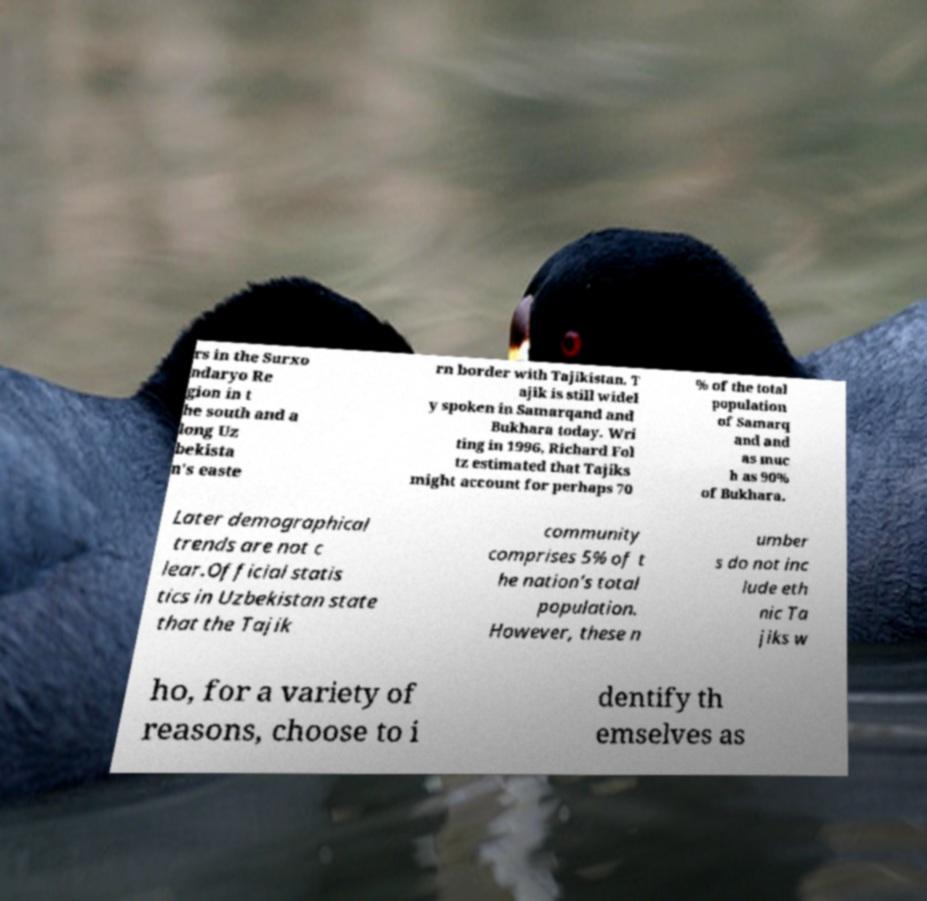There's text embedded in this image that I need extracted. Can you transcribe it verbatim? rs in the Surxo ndaryo Re gion in t he south and a long Uz bekista n's easte rn border with Tajikistan. T ajik is still widel y spoken in Samarqand and Bukhara today. Wri ting in 1996, Richard Fol tz estimated that Tajiks might account for perhaps 70 % of the total population of Samarq and and as muc h as 90% of Bukhara. Later demographical trends are not c lear.Official statis tics in Uzbekistan state that the Tajik community comprises 5% of t he nation's total population. However, these n umber s do not inc lude eth nic Ta jiks w ho, for a variety of reasons, choose to i dentify th emselves as 